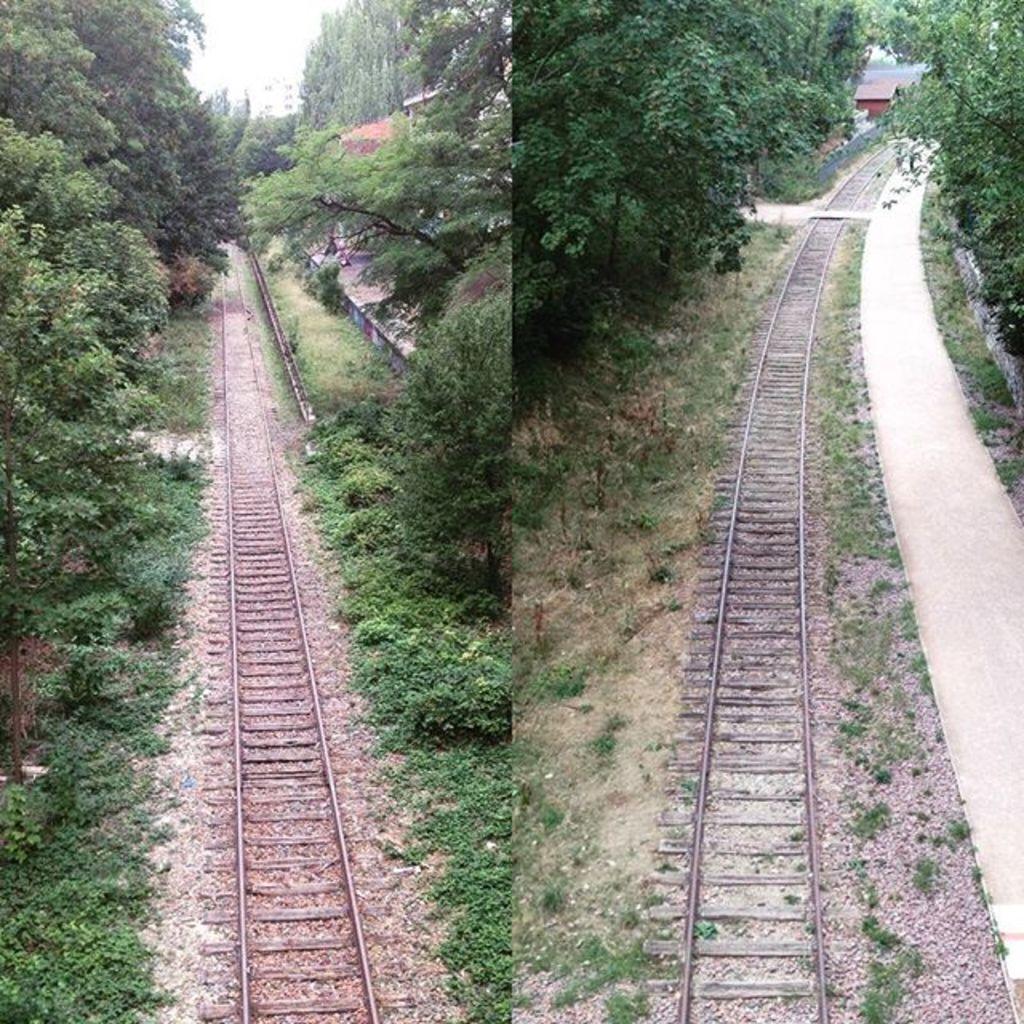In one or two sentences, can you explain what this image depicts? In this I can see a collage picture in which I can see a railway track. On the left and right side, I can see the trees. 